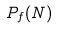Convert formula to latex. <formula><loc_0><loc_0><loc_500><loc_500>P _ { f } ( N )</formula> 